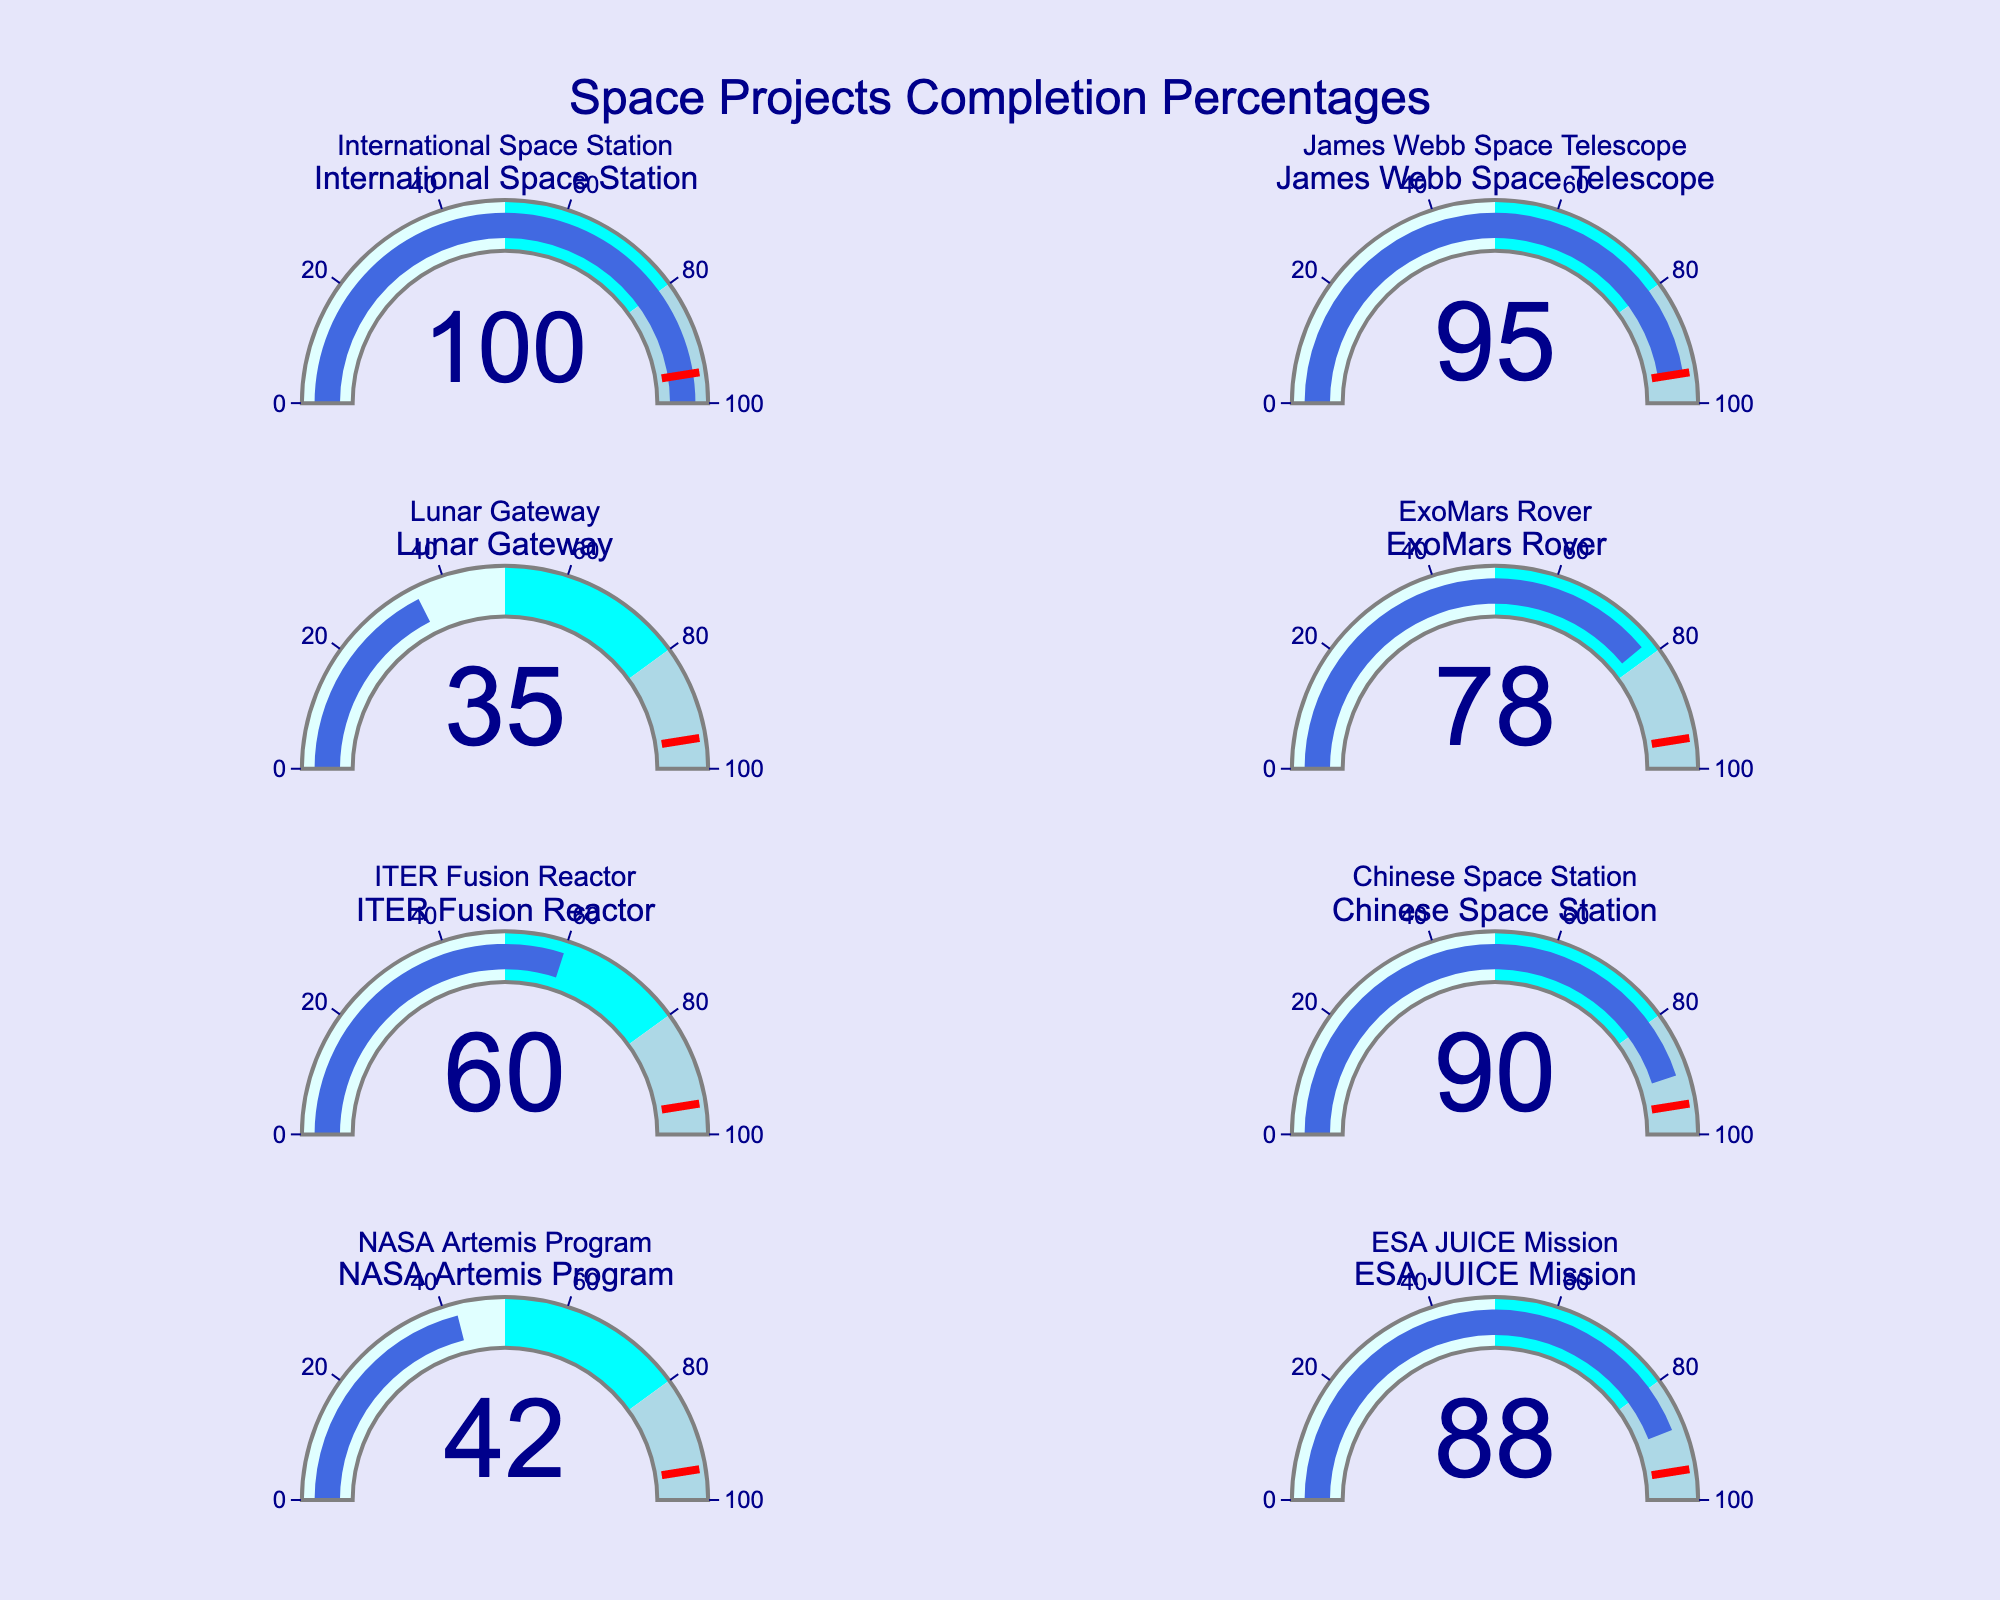What is the title of the figure? The title is usually positioned prominently at the top of the figure. Here it is mentioned in the figure layout.
Answer: Space Projects Completion Percentages What is the completion percentage of the James Webb Space Telescope? Look at the gauge for the James Webb Space Telescope and read the number displayed in the center of the gauge.
Answer: 95 Which project has the highest completion percentage? Look at all the gauges and identify which one shows the highest percentage. The International Space Station shows 100%.
Answer: International Space Station How many projects have a completion percentage of 80% or higher? Count the number of gauges that show a percentage of 80 or higher. These are: International Space Station (100), James Webb Space Telescope (95), Chinese Space Station (90), and ESA JUICE Mission (88).
Answer: 4 What is the range of completion percentages shown in the figure? Identify the minimum and maximum percentages displayed on the gauges. The minimum is 35 (Lunar Gateway) and the maximum is 100 (International Space Station). The range is 100 - 35.
Answer: 65 How much more completed is the ExoMars Rover project compared to the NASA Artemis Program? Determine the completion percentages of both projects and subtract the smaller from the larger: 78 (ExoMars Rover) - 42 (NASA Artemis Program) = 36.
Answer: 36 Which project is closest to the 50% completion mark? Look at the gauges and find the percentage closest to 50%. The NASA Artemis Program shows 42%.
Answer: NASA Artemis Program What percentage of completion marks the threshold line in the gauges? Identify the value marked by the red threshold line in any of the gauges. This value is consistent across all gauges.
Answer: 95% Which project lies in the cyan-colored range of the gauge? Determine which projects have completion percentages within the range of 50 to 80, indicated by the cyan color. The ExoMars Rover (78) and ITER Fusion Reactor (60) fall in this category.
Answer: ExoMars Rover, ITER Fusion Reactor What is the average completion percentage of the listed space projects? Add all the completion percentages (100, 95, 35, 78, 60, 90, 42, 88) and divide the sum by the number of projects: (100 + 95 + 35 + 78 + 60 + 90 + 42 + 88) / 8 = 73.5.
Answer: 73.5 